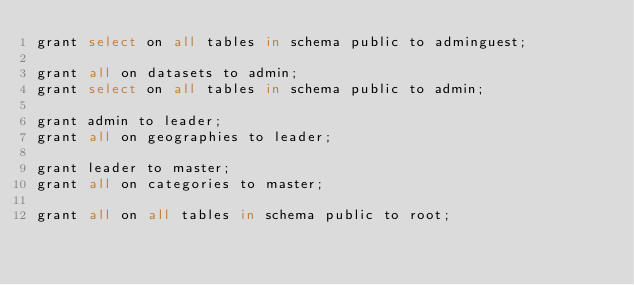<code> <loc_0><loc_0><loc_500><loc_500><_SQL_>grant select on all tables in schema public to adminguest;

grant all on datasets to admin;
grant select on all tables in schema public to admin;

grant admin to leader;
grant all on geographies to leader;

grant leader to master;
grant all on categories to master;

grant all on all tables in schema public to root;
</code> 